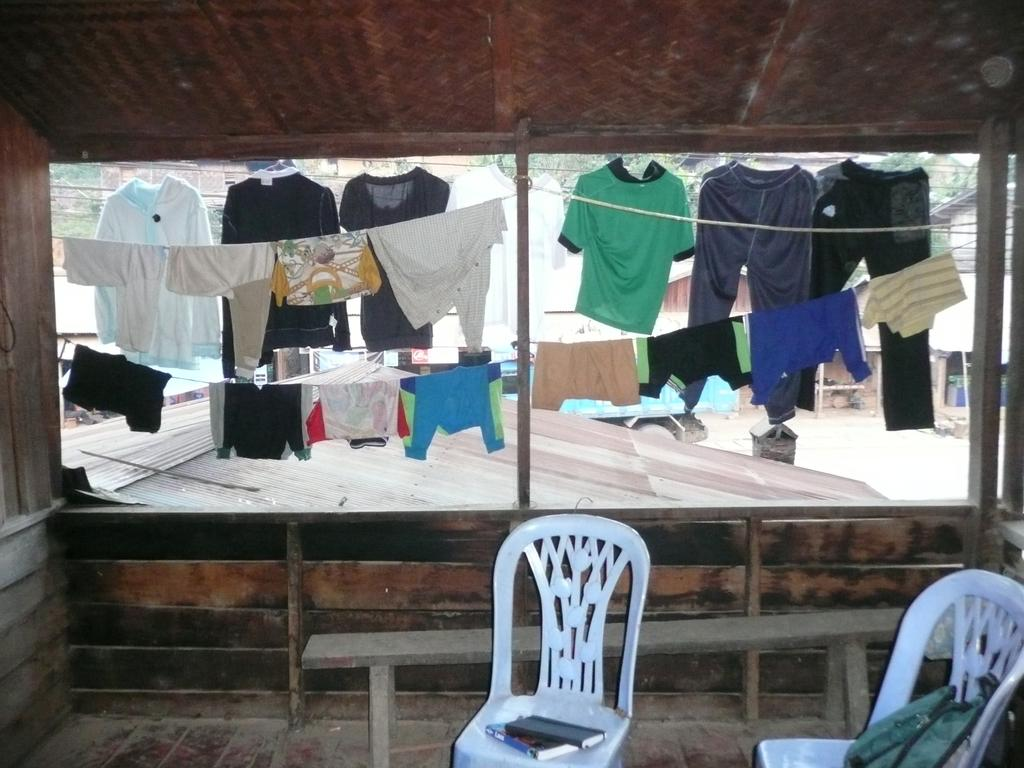What type of seating is visible in the image? There is a bench and chairs in the image. What is placed on the chairs? Books and a bag are placed on the chairs. What can be seen hanging through the window in the image? Clothes are hanged on a rope, visible through a window. What is present on the road in the image? There is a vehicle on the road in the image. What type of vegetation is visible in the image? Trees are visible in the image. What other structures are present in the image? Wires and a wooden pole are present in the image. How many clocks are hanging on the wall in the image? There are no clocks visible in the image. What type of wound can be seen on the person sitting on the bench? There is no person sitting on the bench, nor is there any wound present in the image. 